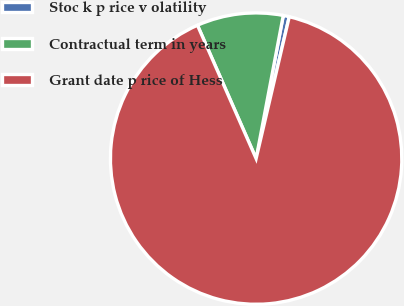Convert chart to OTSL. <chart><loc_0><loc_0><loc_500><loc_500><pie_chart><fcel>Stoc k p rice v olatility<fcel>Contractual term in years<fcel>Grant date p rice of Hess<nl><fcel>0.67%<fcel>9.58%<fcel>89.75%<nl></chart> 